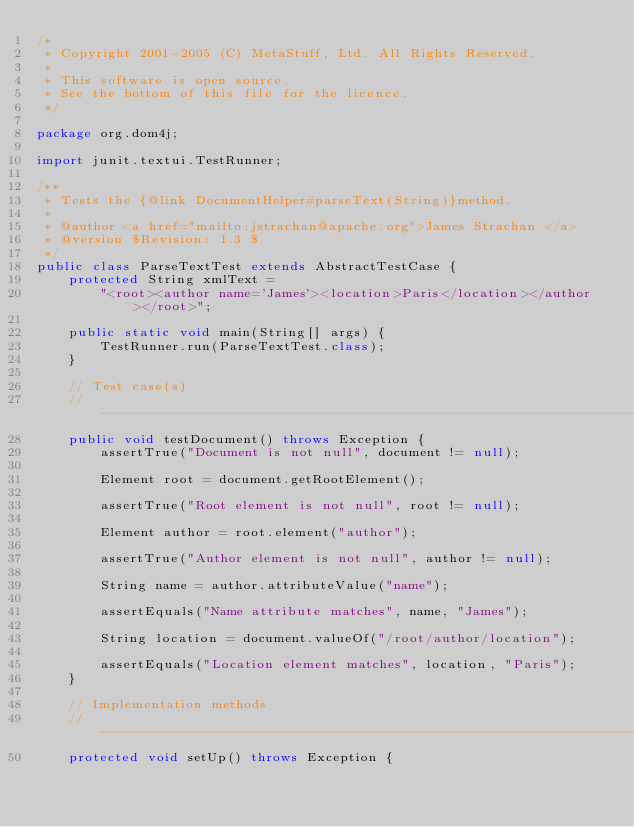Convert code to text. <code><loc_0><loc_0><loc_500><loc_500><_Java_>/*
 * Copyright 2001-2005 (C) MetaStuff, Ltd. All Rights Reserved.
 *
 * This software is open source.
 * See the bottom of this file for the licence.
 */

package org.dom4j;

import junit.textui.TestRunner;

/**
 * Tests the {@link DocumentHelper#parseText(String)}method.
 * 
 * @author <a href="mailto:jstrachan@apache.org">James Strachan </a>
 * @version $Revision: 1.3 $
 */
public class ParseTextTest extends AbstractTestCase {
    protected String xmlText = 
        "<root><author name='James'><location>Paris</location></author></root>";

    public static void main(String[] args) {
        TestRunner.run(ParseTextTest.class);
    }

    // Test case(s)
    // -------------------------------------------------------------------------
    public void testDocument() throws Exception {
        assertTrue("Document is not null", document != null);

        Element root = document.getRootElement();

        assertTrue("Root element is not null", root != null);

        Element author = root.element("author");

        assertTrue("Author element is not null", author != null);

        String name = author.attributeValue("name");

        assertEquals("Name attribute matches", name, "James");

        String location = document.valueOf("/root/author/location");

        assertEquals("Location element matches", location, "Paris");
    }

    // Implementation methods
    // -------------------------------------------------------------------------
    protected void setUp() throws Exception {</code> 